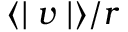<formula> <loc_0><loc_0><loc_500><loc_500>\langle | v | \rangle / r</formula> 